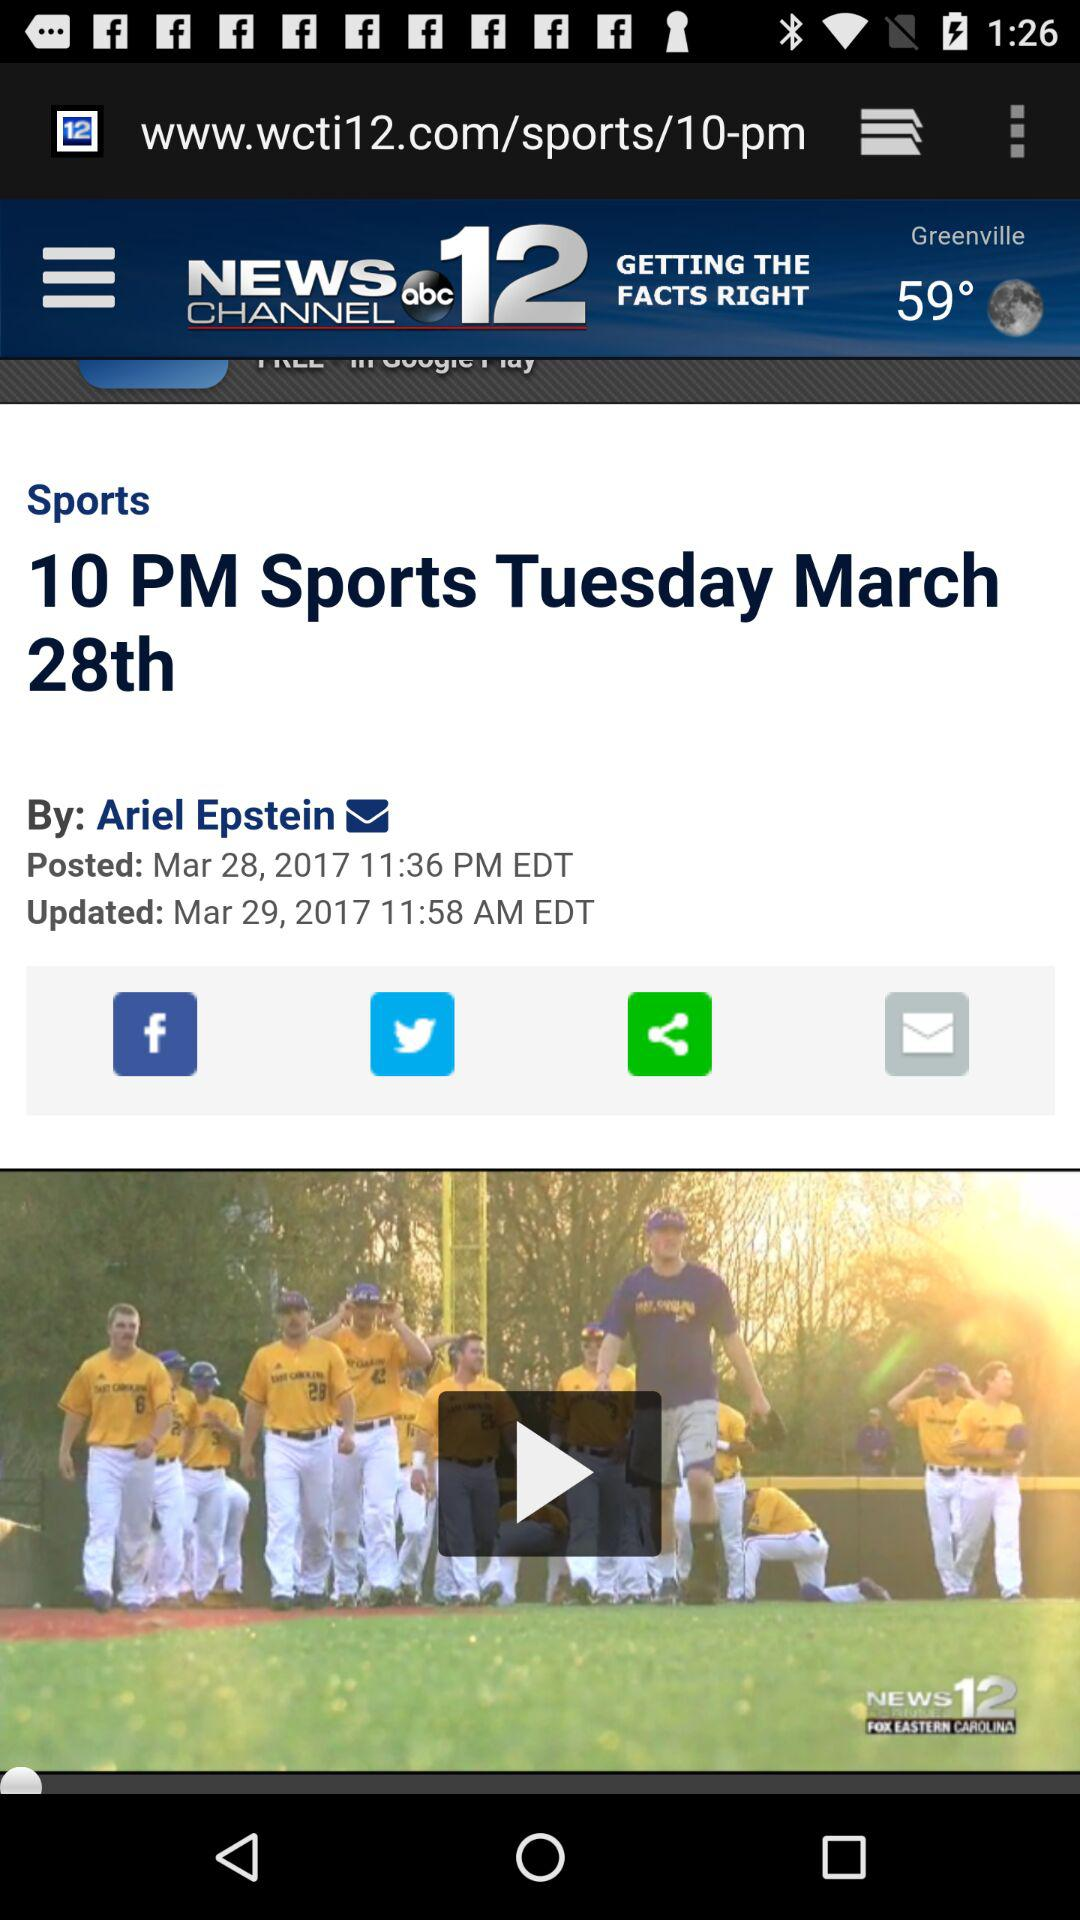What is the weather in Greenville? The weather is clear at night. 